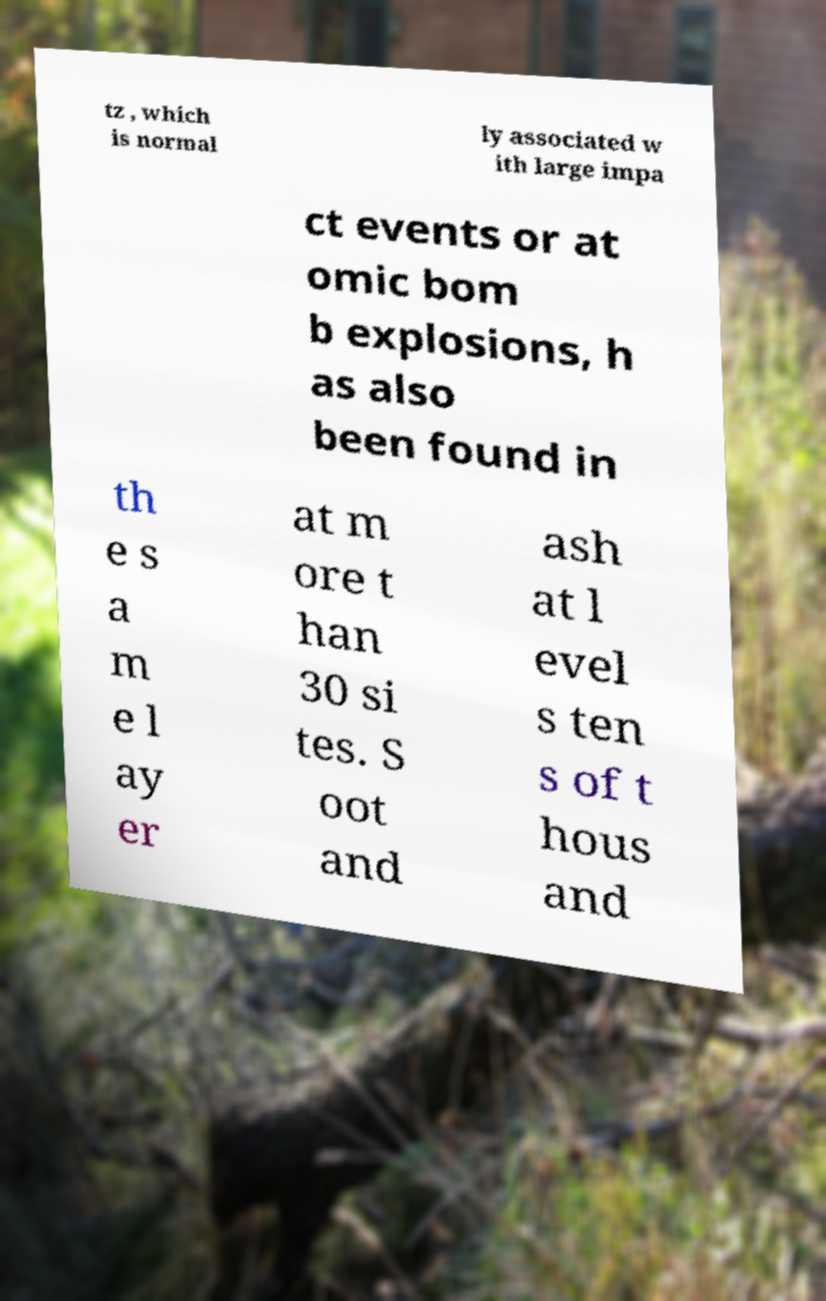Can you accurately transcribe the text from the provided image for me? tz , which is normal ly associated w ith large impa ct events or at omic bom b explosions, h as also been found in th e s a m e l ay er at m ore t han 30 si tes. S oot and ash at l evel s ten s of t hous and 